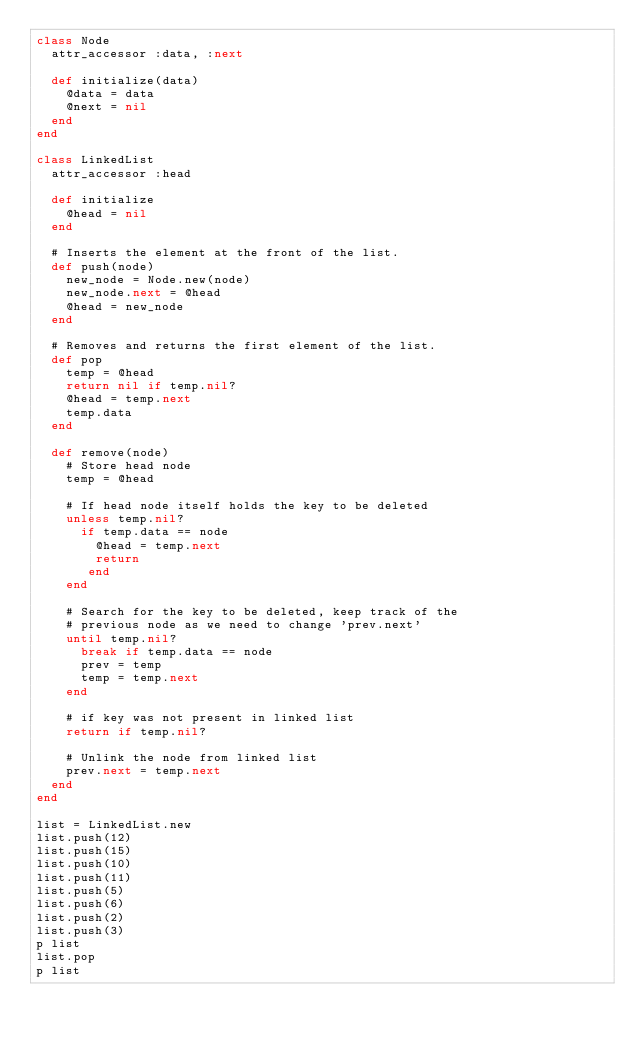Convert code to text. <code><loc_0><loc_0><loc_500><loc_500><_Ruby_>class Node
  attr_accessor :data, :next

  def initialize(data)
    @data = data
    @next = nil
  end
end

class LinkedList
  attr_accessor :head
  
  def initialize
    @head = nil
  end

  # Inserts the element at the front of the list.
  def push(node)
    new_node = Node.new(node)
    new_node.next = @head
    @head = new_node
  end

  # Removes and returns the first element of the list.
  def pop
    temp = @head
    return nil if temp.nil?
    @head = temp.next
    temp.data
  end

  def remove(node)
    # Store head node
    temp = @head

    # If head node itself holds the key to be deleted
    unless temp.nil?
      if temp.data == node
        @head = temp.next
        return
       end
    end

    # Search for the key to be deleted, keep track of the
    # previous node as we need to change 'prev.next'
    until temp.nil?
      break if temp.data == node
      prev = temp
      temp = temp.next
    end

    # if key was not present in linked list
    return if temp.nil?

    # Unlink the node from linked list
    prev.next = temp.next
  end
end

list = LinkedList.new
list.push(12)
list.push(15)
list.push(10)
list.push(11)
list.push(5)
list.push(6)
list.push(2)
list.push(3)
p list
list.pop
p list
</code> 